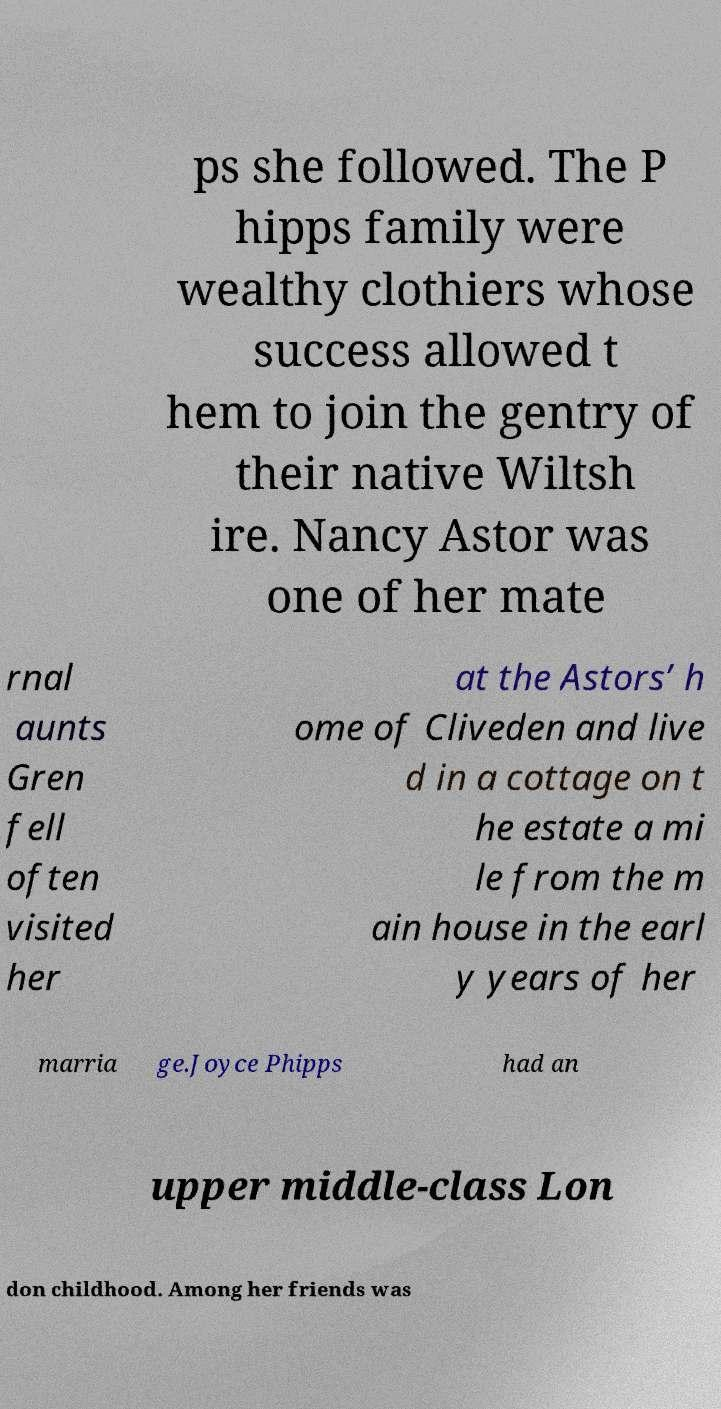Please identify and transcribe the text found in this image. ps she followed. The P hipps family were wealthy clothiers whose success allowed t hem to join the gentry of their native Wiltsh ire. Nancy Astor was one of her mate rnal aunts Gren fell often visited her at the Astors’ h ome of Cliveden and live d in a cottage on t he estate a mi le from the m ain house in the earl y years of her marria ge.Joyce Phipps had an upper middle-class Lon don childhood. Among her friends was 